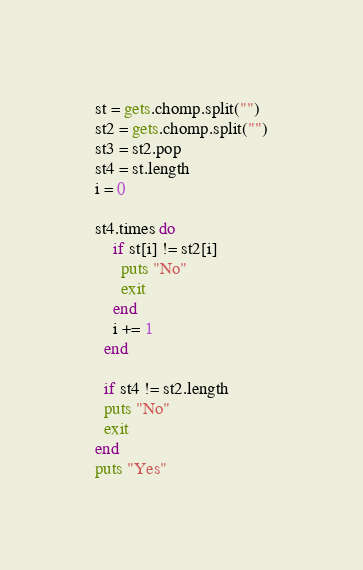<code> <loc_0><loc_0><loc_500><loc_500><_Ruby_>st = gets.chomp.split("")
st2 = gets.chomp.split("")
st3 = st2.pop
st4 = st.length
i = 0

st4.times do
    if st[i] != st2[i]
      puts "No"
      exit
    end
    i += 1
  end

  if st4 != st2.length
  puts "No"
  exit
end
puts "Yes"
</code> 